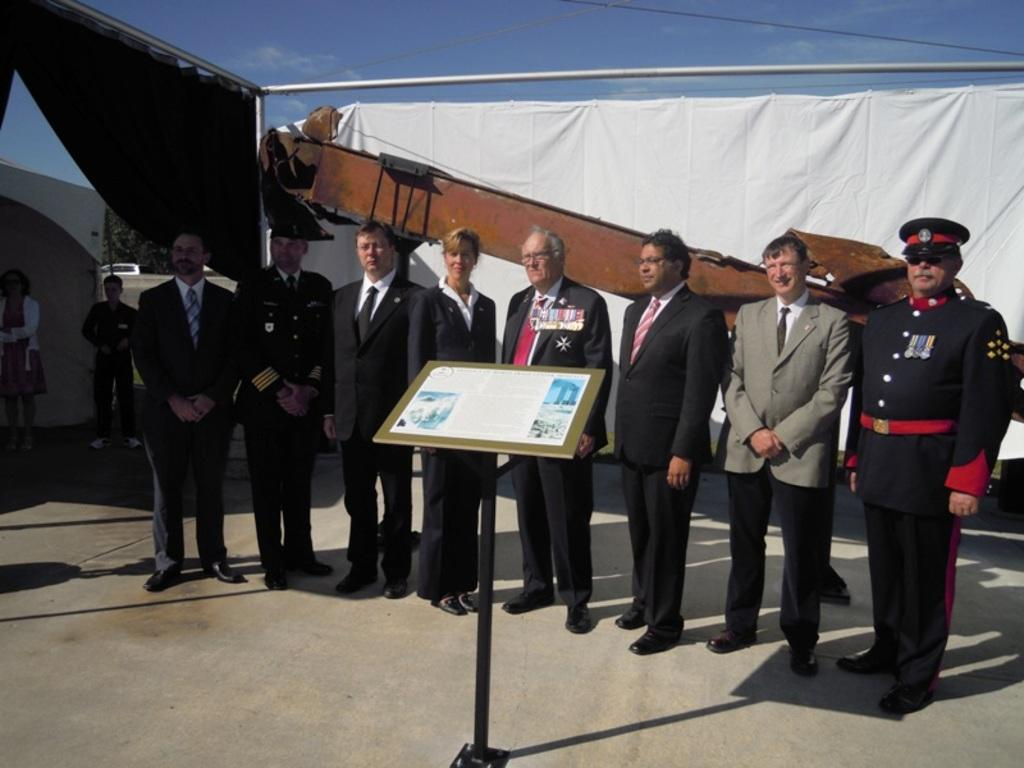What is happening in the center of the image? There are people standing in the center of the image. What is in front of the people? There is a desk in front of the people. Can you describe the background area of the image? In the background area, there are people, curtains, wires, a tree, a vehicle, and the sky. What type of egg is being used by the giants in the image? There are no giants or eggs present in the image. What tool are the people using to fix the wrench in the image? There is no wrench present in the image, and therefore no tool is being used to fix it. 